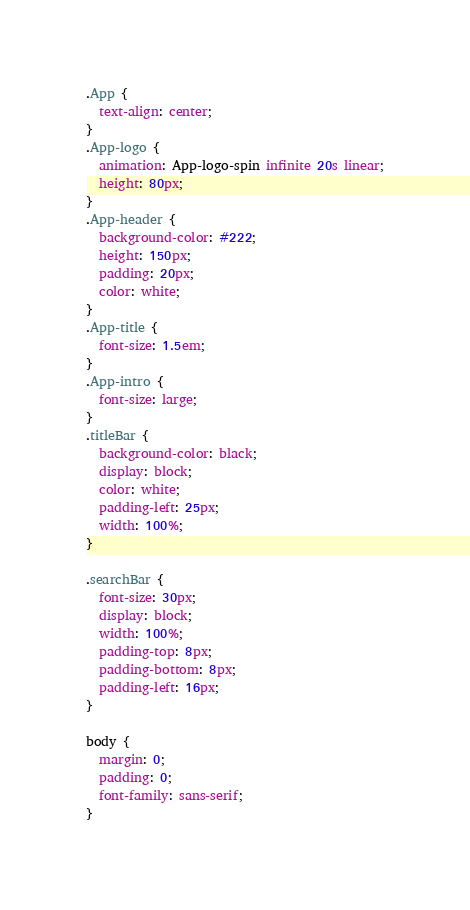<code> <loc_0><loc_0><loc_500><loc_500><_CSS_>.App {
  text-align: center;
}
.App-logo {
  animation: App-logo-spin infinite 20s linear;
  height: 80px;
}
.App-header {
  background-color: #222;
  height: 150px;
  padding: 20px;
  color: white;
}
.App-title {
  font-size: 1.5em;
}
.App-intro {
  font-size: large;
}
.titleBar {
  background-color: black;
  display: block;
  color: white;
  padding-left: 25px;
  width: 100%;
}

.searchBar {
  font-size: 30px;
  display: block;
  width: 100%;
  padding-top: 8px;
  padding-bottom: 8px;
  padding-left: 16px;
}

body {
  margin: 0;
  padding: 0;
  font-family: sans-serif;
}</code> 